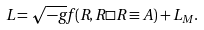Convert formula to latex. <formula><loc_0><loc_0><loc_500><loc_500>L = \sqrt { - g } f ( R , R \Box R \equiv A ) + L _ { M } .</formula> 